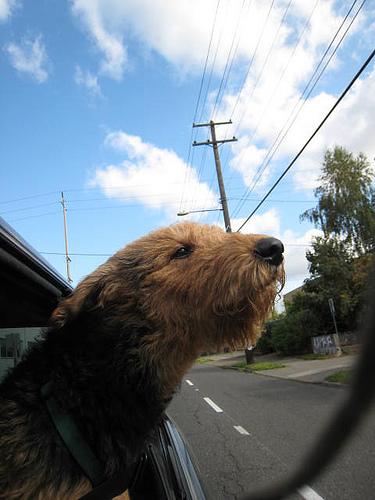Is the dog driving?
Concise answer only. No. What color is the dog's nose?
Concise answer only. Black. From the wind blowing the fur of the dog how fast are they going?
Write a very short answer. 30 mph. 